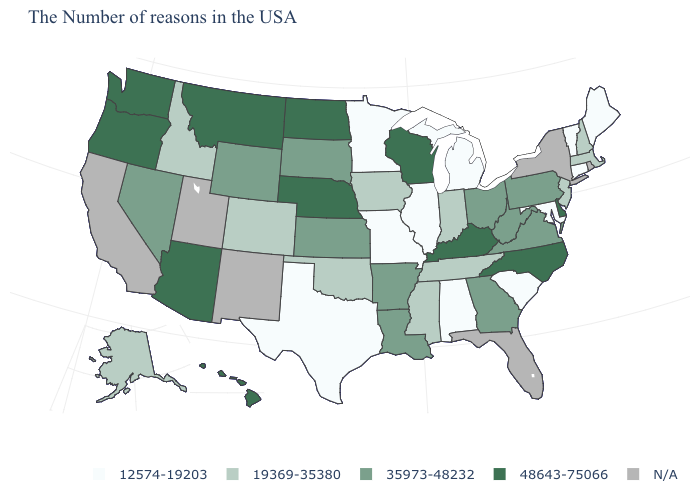What is the value of Oregon?
Concise answer only. 48643-75066. Which states have the lowest value in the USA?
Be succinct. Maine, Vermont, Connecticut, Maryland, South Carolina, Michigan, Alabama, Illinois, Missouri, Minnesota, Texas. What is the value of Virginia?
Concise answer only. 35973-48232. What is the value of Washington?
Short answer required. 48643-75066. What is the highest value in the USA?
Be succinct. 48643-75066. Name the states that have a value in the range 19369-35380?
Be succinct. Massachusetts, New Hampshire, New Jersey, Indiana, Tennessee, Mississippi, Iowa, Oklahoma, Colorado, Idaho, Alaska. Does Maine have the lowest value in the USA?
Quick response, please. Yes. Name the states that have a value in the range 48643-75066?
Be succinct. Delaware, North Carolina, Kentucky, Wisconsin, Nebraska, North Dakota, Montana, Arizona, Washington, Oregon, Hawaii. Among the states that border Nebraska , does Missouri have the lowest value?
Short answer required. Yes. Name the states that have a value in the range 48643-75066?
Concise answer only. Delaware, North Carolina, Kentucky, Wisconsin, Nebraska, North Dakota, Montana, Arizona, Washington, Oregon, Hawaii. Does Mississippi have the highest value in the USA?
Be succinct. No. What is the lowest value in states that border Oregon?
Answer briefly. 19369-35380. Does Washington have the lowest value in the West?
Concise answer only. No. What is the lowest value in the USA?
Write a very short answer. 12574-19203. 